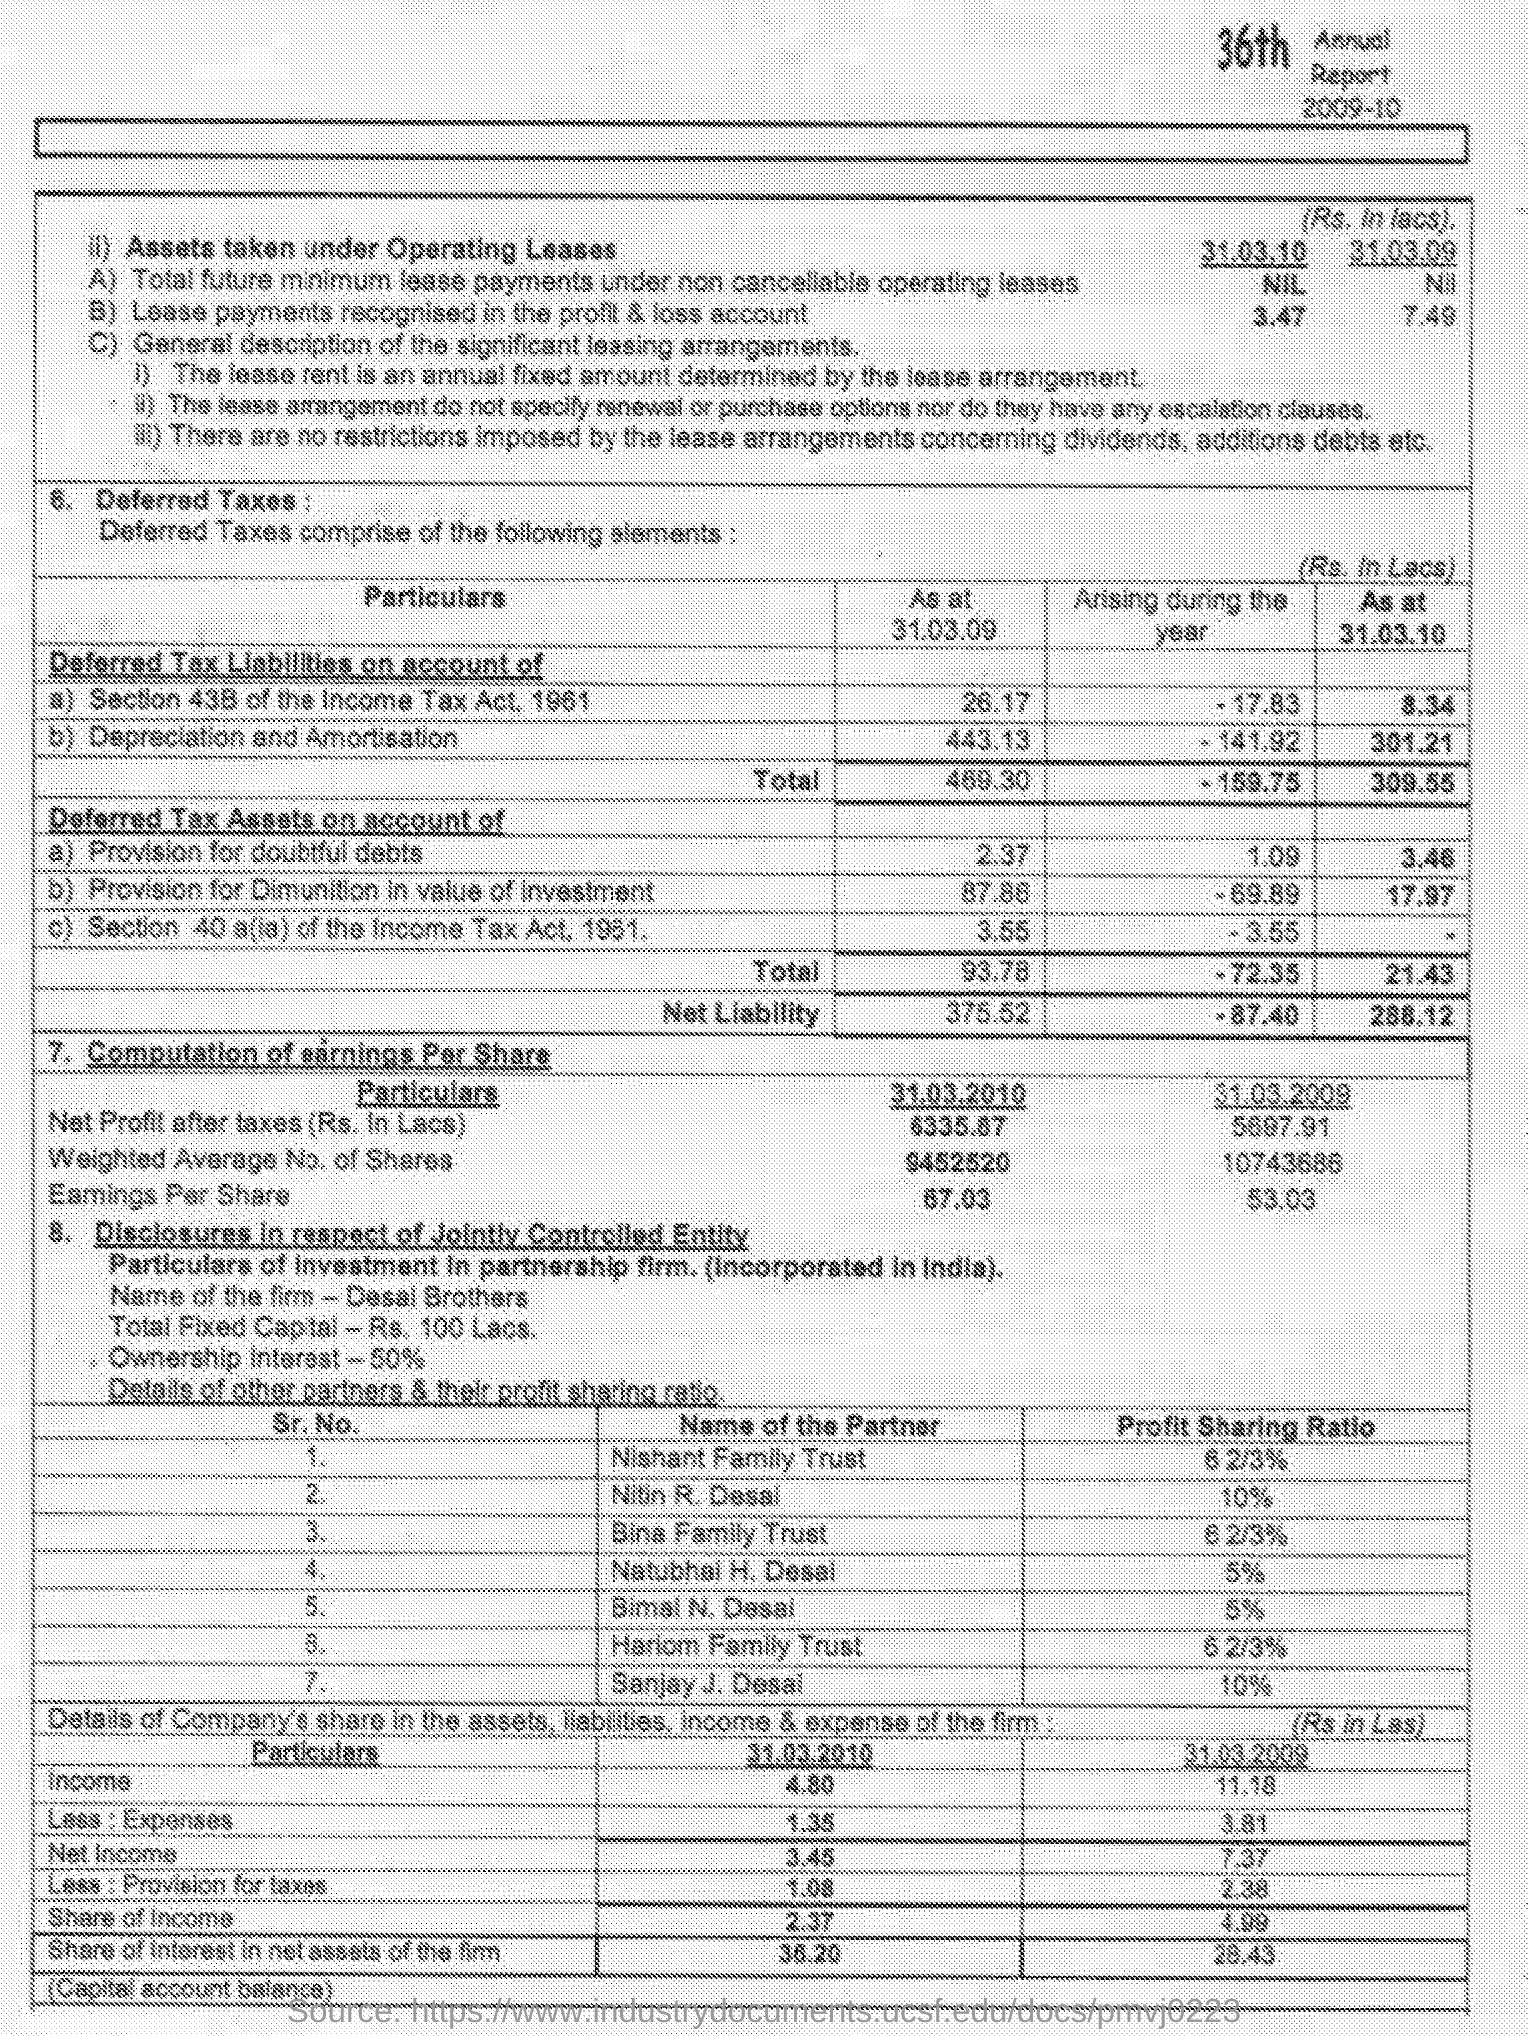What is the profit-sharing ratio of Nitin R. Desai?
Offer a terse response. 10%. What is the name of the firm?
Your answer should be compact. Desai Brothers. What is the Ownership Interest?
Keep it short and to the point. 50%. What is the total fixed capital?
Your response must be concise. Rs. 100 Lacs. What is the profit-sharing ratio of Sanjay J. Desai?
Keep it short and to the point. 10%. 